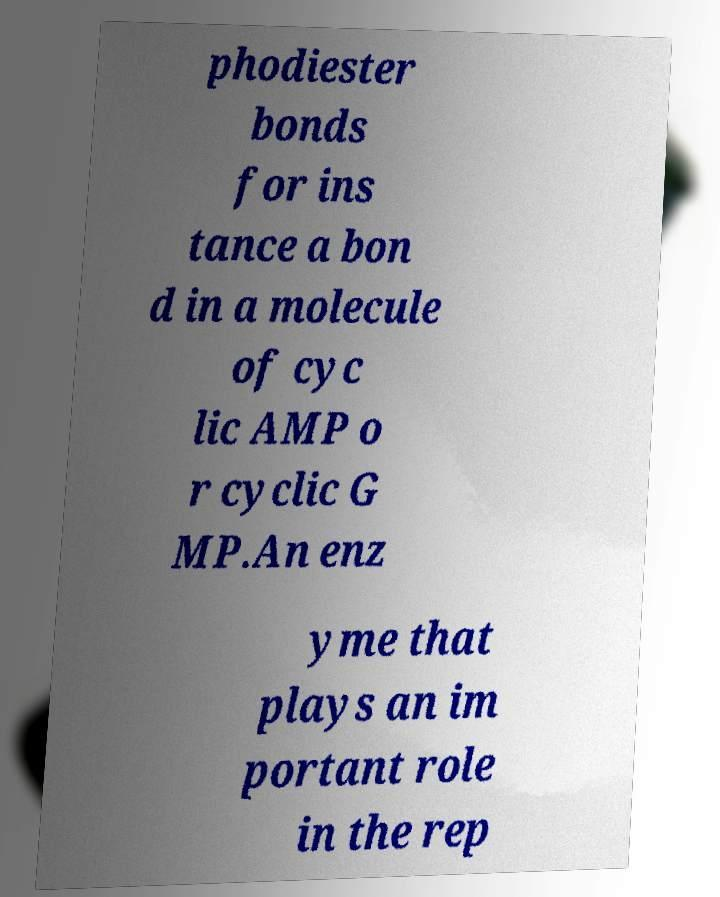Please identify and transcribe the text found in this image. phodiester bonds for ins tance a bon d in a molecule of cyc lic AMP o r cyclic G MP.An enz yme that plays an im portant role in the rep 